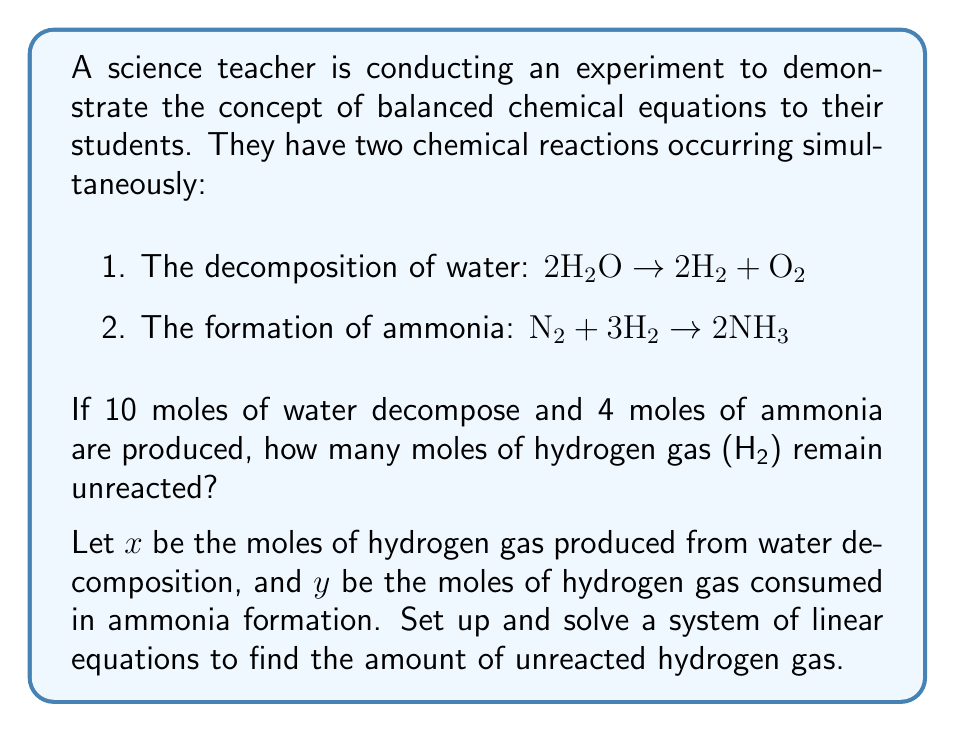Solve this math problem. Let's approach this step-by-step:

1) First, let's set up our equations based on the given information:

   For water decomposition: $x = 2 \cdot 10 = 20$ moles of H₂ produced
   (Since 2 moles of H₂ are produced for every 2 moles of H₂O decomposed)

   For ammonia formation: $y = 3 \cdot 2 = 6$ moles of H₂ consumed
   (Since 3 moles of H₂ are needed to produce 2 moles of NH₃, and 4 moles of NH₃ were produced)

2) Now we can set up our system of linear equations:

   $$\begin{cases}
   x = 20 \\
   y = 6
   \end{cases}$$

3) The amount of unreacted hydrogen gas will be the difference between the amount produced and the amount consumed:

   Unreacted H₂ = $x - y = 20 - 6 = 14$ moles

Therefore, 14 moles of hydrogen gas remain unreacted.
Answer: 14 moles of H₂ 